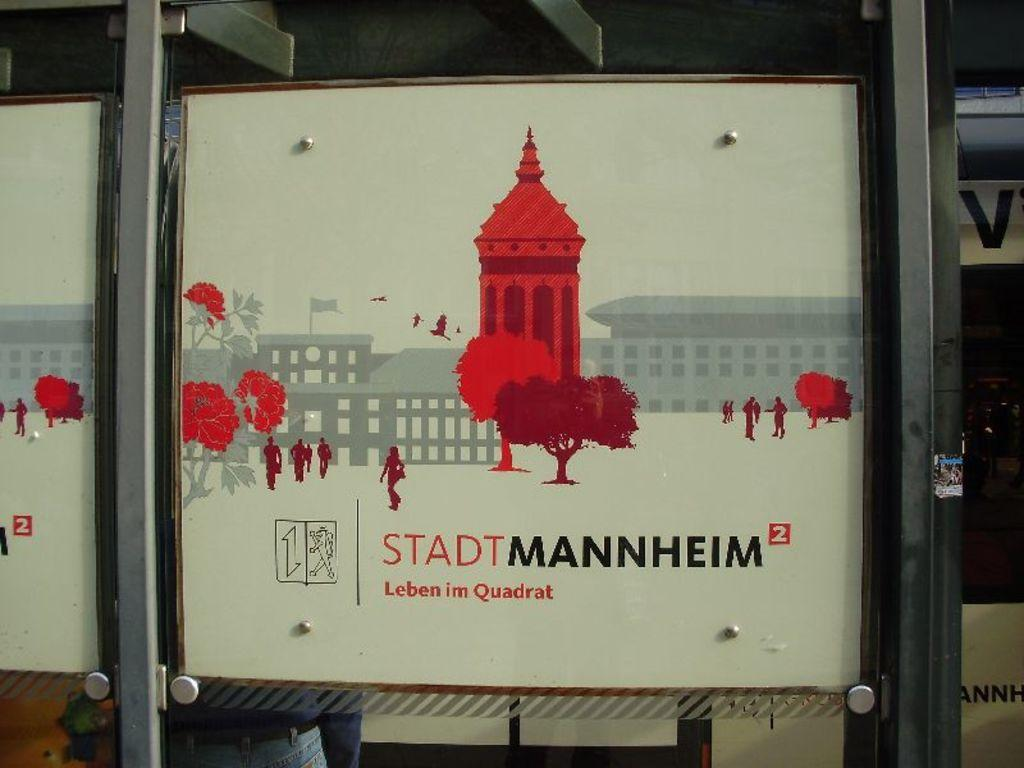What type of door is visible in the image? There is a glass door in the image. What is displayed on the poster in the image? The poster in the image has text and images. Can you describe the person visible through the glass door? Unfortunately, the provided facts do not give any information about the person's appearance or actions. What scientific theory is being discussed in the story depicted on the poster? There is no story or scientific theory mentioned in the provided facts. The poster only has text and images, but their content is not specified. 